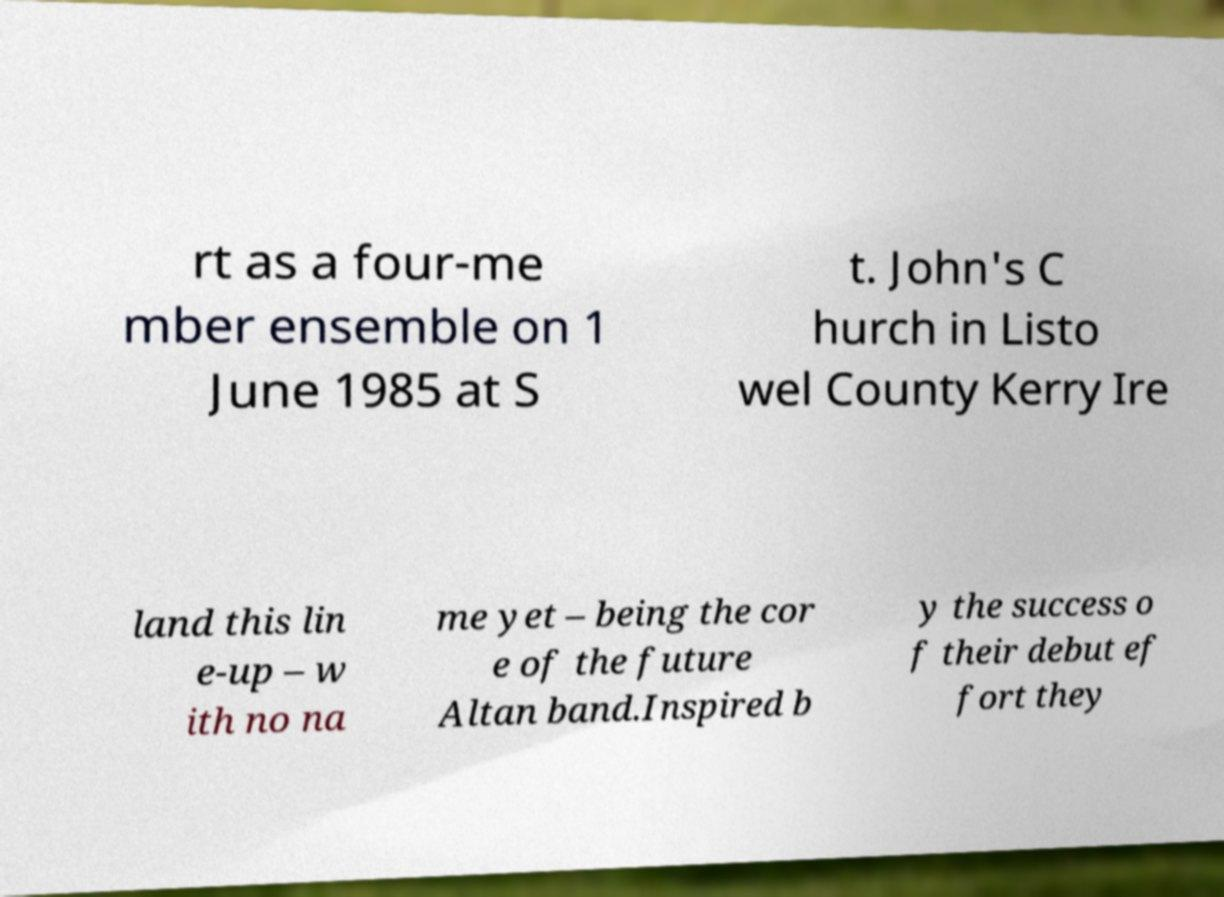What messages or text are displayed in this image? I need them in a readable, typed format. rt as a four-me mber ensemble on 1 June 1985 at S t. John's C hurch in Listo wel County Kerry Ire land this lin e-up – w ith no na me yet – being the cor e of the future Altan band.Inspired b y the success o f their debut ef fort they 